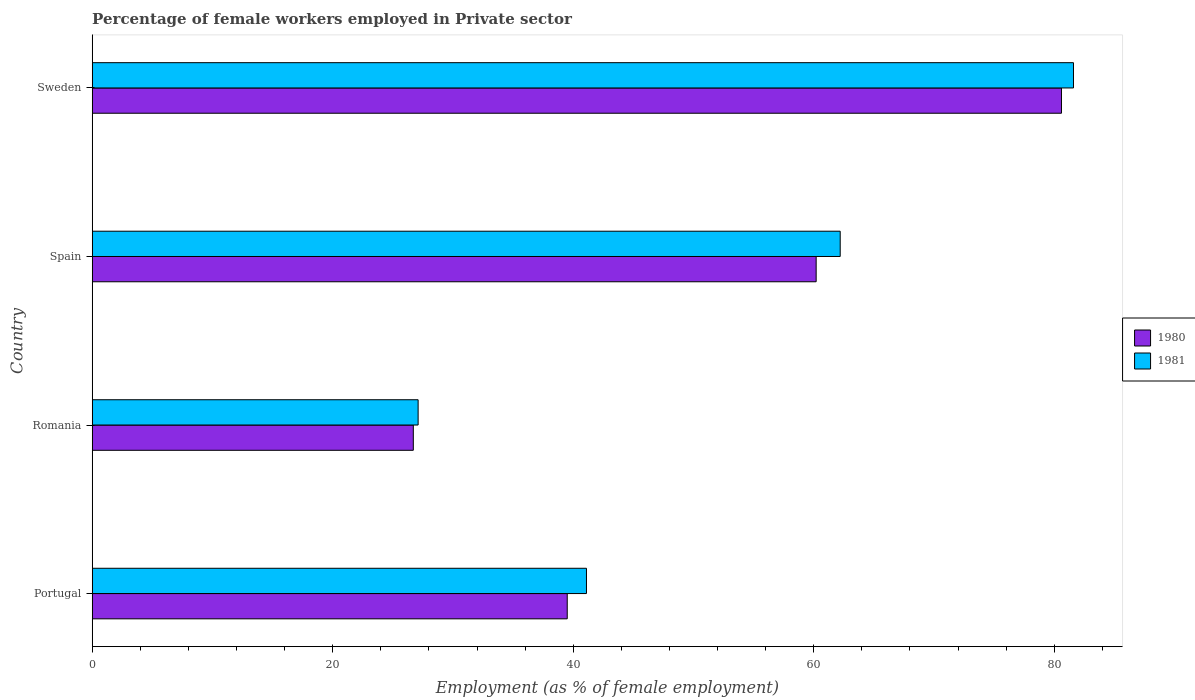How many different coloured bars are there?
Give a very brief answer. 2. How many bars are there on the 1st tick from the bottom?
Your response must be concise. 2. In how many cases, is the number of bars for a given country not equal to the number of legend labels?
Your response must be concise. 0. What is the percentage of females employed in Private sector in 1981 in Portugal?
Offer a very short reply. 41.1. Across all countries, what is the maximum percentage of females employed in Private sector in 1981?
Ensure brevity in your answer.  81.6. Across all countries, what is the minimum percentage of females employed in Private sector in 1981?
Ensure brevity in your answer.  27.1. In which country was the percentage of females employed in Private sector in 1980 minimum?
Make the answer very short. Romania. What is the total percentage of females employed in Private sector in 1980 in the graph?
Your response must be concise. 207. What is the difference between the percentage of females employed in Private sector in 1981 in Romania and that in Sweden?
Give a very brief answer. -54.5. What is the difference between the percentage of females employed in Private sector in 1981 in Spain and the percentage of females employed in Private sector in 1980 in Romania?
Offer a terse response. 35.5. What is the average percentage of females employed in Private sector in 1980 per country?
Your response must be concise. 51.75. What is the ratio of the percentage of females employed in Private sector in 1980 in Portugal to that in Sweden?
Offer a very short reply. 0.49. What is the difference between the highest and the second highest percentage of females employed in Private sector in 1980?
Give a very brief answer. 20.4. What is the difference between the highest and the lowest percentage of females employed in Private sector in 1981?
Your answer should be compact. 54.5. In how many countries, is the percentage of females employed in Private sector in 1980 greater than the average percentage of females employed in Private sector in 1980 taken over all countries?
Make the answer very short. 2. Is the sum of the percentage of females employed in Private sector in 1980 in Romania and Spain greater than the maximum percentage of females employed in Private sector in 1981 across all countries?
Offer a terse response. Yes. What does the 1st bar from the bottom in Romania represents?
Your answer should be compact. 1980. How many bars are there?
Make the answer very short. 8. What is the difference between two consecutive major ticks on the X-axis?
Give a very brief answer. 20. Are the values on the major ticks of X-axis written in scientific E-notation?
Ensure brevity in your answer.  No. Does the graph contain any zero values?
Give a very brief answer. No. Does the graph contain grids?
Provide a succinct answer. No. How many legend labels are there?
Provide a succinct answer. 2. How are the legend labels stacked?
Ensure brevity in your answer.  Vertical. What is the title of the graph?
Give a very brief answer. Percentage of female workers employed in Private sector. What is the label or title of the X-axis?
Your answer should be very brief. Employment (as % of female employment). What is the Employment (as % of female employment) in 1980 in Portugal?
Offer a very short reply. 39.5. What is the Employment (as % of female employment) in 1981 in Portugal?
Provide a short and direct response. 41.1. What is the Employment (as % of female employment) of 1980 in Romania?
Your response must be concise. 26.7. What is the Employment (as % of female employment) in 1981 in Romania?
Your answer should be very brief. 27.1. What is the Employment (as % of female employment) in 1980 in Spain?
Offer a very short reply. 60.2. What is the Employment (as % of female employment) in 1981 in Spain?
Give a very brief answer. 62.2. What is the Employment (as % of female employment) of 1980 in Sweden?
Your answer should be very brief. 80.6. What is the Employment (as % of female employment) of 1981 in Sweden?
Your answer should be very brief. 81.6. Across all countries, what is the maximum Employment (as % of female employment) in 1980?
Keep it short and to the point. 80.6. Across all countries, what is the maximum Employment (as % of female employment) in 1981?
Provide a short and direct response. 81.6. Across all countries, what is the minimum Employment (as % of female employment) in 1980?
Ensure brevity in your answer.  26.7. Across all countries, what is the minimum Employment (as % of female employment) in 1981?
Provide a succinct answer. 27.1. What is the total Employment (as % of female employment) in 1980 in the graph?
Your answer should be very brief. 207. What is the total Employment (as % of female employment) of 1981 in the graph?
Ensure brevity in your answer.  212. What is the difference between the Employment (as % of female employment) in 1981 in Portugal and that in Romania?
Keep it short and to the point. 14. What is the difference between the Employment (as % of female employment) in 1980 in Portugal and that in Spain?
Offer a very short reply. -20.7. What is the difference between the Employment (as % of female employment) of 1981 in Portugal and that in Spain?
Offer a very short reply. -21.1. What is the difference between the Employment (as % of female employment) in 1980 in Portugal and that in Sweden?
Provide a succinct answer. -41.1. What is the difference between the Employment (as % of female employment) in 1981 in Portugal and that in Sweden?
Keep it short and to the point. -40.5. What is the difference between the Employment (as % of female employment) of 1980 in Romania and that in Spain?
Provide a short and direct response. -33.5. What is the difference between the Employment (as % of female employment) of 1981 in Romania and that in Spain?
Give a very brief answer. -35.1. What is the difference between the Employment (as % of female employment) of 1980 in Romania and that in Sweden?
Ensure brevity in your answer.  -53.9. What is the difference between the Employment (as % of female employment) in 1981 in Romania and that in Sweden?
Your answer should be very brief. -54.5. What is the difference between the Employment (as % of female employment) of 1980 in Spain and that in Sweden?
Your answer should be compact. -20.4. What is the difference between the Employment (as % of female employment) in 1981 in Spain and that in Sweden?
Keep it short and to the point. -19.4. What is the difference between the Employment (as % of female employment) of 1980 in Portugal and the Employment (as % of female employment) of 1981 in Spain?
Ensure brevity in your answer.  -22.7. What is the difference between the Employment (as % of female employment) of 1980 in Portugal and the Employment (as % of female employment) of 1981 in Sweden?
Give a very brief answer. -42.1. What is the difference between the Employment (as % of female employment) in 1980 in Romania and the Employment (as % of female employment) in 1981 in Spain?
Ensure brevity in your answer.  -35.5. What is the difference between the Employment (as % of female employment) in 1980 in Romania and the Employment (as % of female employment) in 1981 in Sweden?
Keep it short and to the point. -54.9. What is the difference between the Employment (as % of female employment) of 1980 in Spain and the Employment (as % of female employment) of 1981 in Sweden?
Provide a succinct answer. -21.4. What is the average Employment (as % of female employment) in 1980 per country?
Provide a short and direct response. 51.75. What is the average Employment (as % of female employment) in 1981 per country?
Provide a succinct answer. 53. What is the difference between the Employment (as % of female employment) of 1980 and Employment (as % of female employment) of 1981 in Portugal?
Keep it short and to the point. -1.6. What is the difference between the Employment (as % of female employment) of 1980 and Employment (as % of female employment) of 1981 in Sweden?
Your answer should be compact. -1. What is the ratio of the Employment (as % of female employment) of 1980 in Portugal to that in Romania?
Provide a succinct answer. 1.48. What is the ratio of the Employment (as % of female employment) of 1981 in Portugal to that in Romania?
Provide a succinct answer. 1.52. What is the ratio of the Employment (as % of female employment) of 1980 in Portugal to that in Spain?
Offer a very short reply. 0.66. What is the ratio of the Employment (as % of female employment) of 1981 in Portugal to that in Spain?
Your response must be concise. 0.66. What is the ratio of the Employment (as % of female employment) in 1980 in Portugal to that in Sweden?
Make the answer very short. 0.49. What is the ratio of the Employment (as % of female employment) in 1981 in Portugal to that in Sweden?
Offer a terse response. 0.5. What is the ratio of the Employment (as % of female employment) in 1980 in Romania to that in Spain?
Offer a terse response. 0.44. What is the ratio of the Employment (as % of female employment) of 1981 in Romania to that in Spain?
Offer a terse response. 0.44. What is the ratio of the Employment (as % of female employment) of 1980 in Romania to that in Sweden?
Provide a short and direct response. 0.33. What is the ratio of the Employment (as % of female employment) in 1981 in Romania to that in Sweden?
Make the answer very short. 0.33. What is the ratio of the Employment (as % of female employment) of 1980 in Spain to that in Sweden?
Offer a terse response. 0.75. What is the ratio of the Employment (as % of female employment) of 1981 in Spain to that in Sweden?
Offer a terse response. 0.76. What is the difference between the highest and the second highest Employment (as % of female employment) in 1980?
Make the answer very short. 20.4. What is the difference between the highest and the lowest Employment (as % of female employment) of 1980?
Offer a terse response. 53.9. What is the difference between the highest and the lowest Employment (as % of female employment) of 1981?
Offer a very short reply. 54.5. 